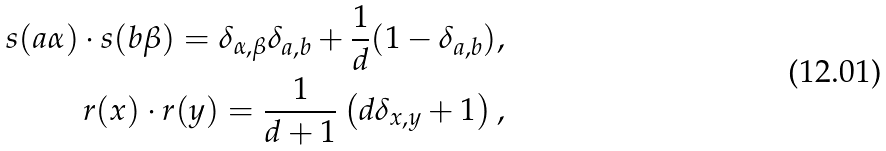<formula> <loc_0><loc_0><loc_500><loc_500>s ( a \alpha ) \cdot s ( b \beta ) = \delta _ { \alpha , \beta } \delta _ { a , b } + \frac { 1 } { d } ( 1 - \delta _ { a , b } ) , \\ r ( x ) \cdot r ( y ) = \frac { 1 } { d + 1 } \left ( d \delta _ { x , y } + 1 \right ) ,</formula> 